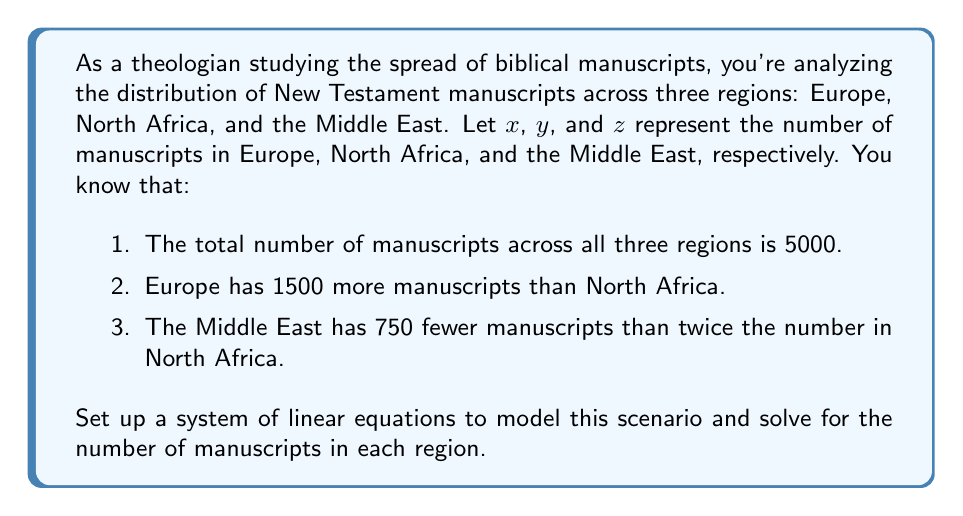Show me your answer to this math problem. Let's approach this step-by-step:

1) First, we'll set up our system of equations based on the given information:

   Equation 1: $x + y + z = 5000$ (total manuscripts)
   Equation 2: $x = y + 1500$ (Europe has 1500 more than North Africa)
   Equation 3: $z = 2y - 750$ (Middle East has 750 fewer than twice North Africa)

2) We can substitute Equation 2 and Equation 3 into Equation 1:

   $(y + 1500) + y + (2y - 750) = 5000$

3) Simplify:

   $4y + 750 = 5000$

4) Solve for $y$:

   $4y = 4250$
   $y = 1062.5$

5) Since we can't have fractional manuscripts, we round to the nearest whole number:

   $y = 1063$ (North Africa)

6) Now we can solve for $x$ and $z$ using Equations 2 and 3:

   $x = 1063 + 1500 = 2563$ (Europe)
   $z = 2(1063) - 750 = 1376$ (Middle East)

7) Let's verify our solution satisfies the original equation:

   $2563 + 1063 + 1376 = 5002$

   The slight discrepancy (5002 instead of 5000) is due to rounding.
Answer: Europe (x): 2563 manuscripts
North Africa (y): 1063 manuscripts
Middle East (z): 1376 manuscripts 